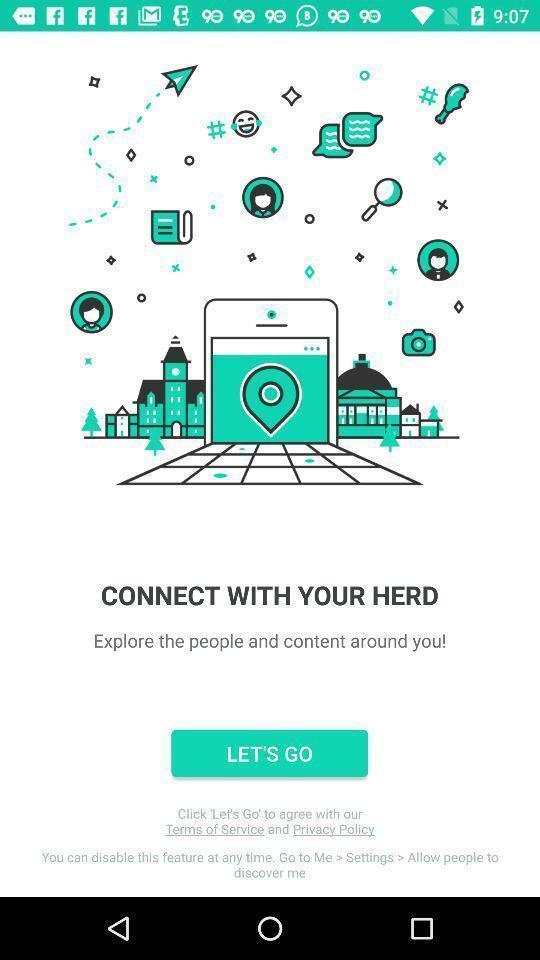Describe the visual elements of this screenshot. Welcome page. 